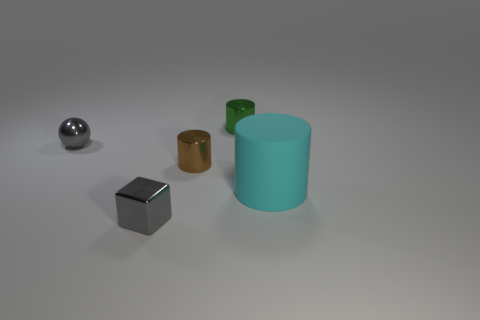What is the material of the large cyan object that is the same shape as the small brown thing? The large cyan object, which shares its cylindrical shape with the small brown item next to it, appears to be made of a matte plastic material, judging by its smooth surface and the way it reflects light. 